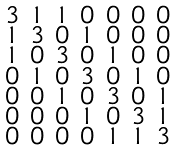Convert formula to latex. <formula><loc_0><loc_0><loc_500><loc_500>\begin{smallmatrix} 3 & 1 & 1 & 0 & 0 & 0 & 0 \\ 1 & 3 & 0 & 1 & 0 & 0 & 0 \\ 1 & 0 & 3 & 0 & 1 & 0 & 0 \\ 0 & 1 & 0 & 3 & 0 & 1 & 0 \\ 0 & 0 & 1 & 0 & 3 & 0 & 1 \\ 0 & 0 & 0 & 1 & 0 & 3 & 1 \\ 0 & 0 & 0 & 0 & 1 & 1 & 3 \end{smallmatrix}</formula> 